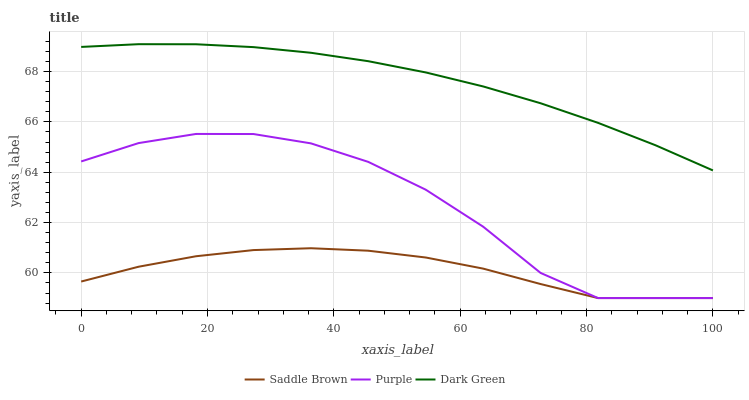Does Saddle Brown have the minimum area under the curve?
Answer yes or no. Yes. Does Dark Green have the maximum area under the curve?
Answer yes or no. Yes. Does Dark Green have the minimum area under the curve?
Answer yes or no. No. Does Saddle Brown have the maximum area under the curve?
Answer yes or no. No. Is Dark Green the smoothest?
Answer yes or no. Yes. Is Purple the roughest?
Answer yes or no. Yes. Is Saddle Brown the smoothest?
Answer yes or no. No. Is Saddle Brown the roughest?
Answer yes or no. No. Does Dark Green have the lowest value?
Answer yes or no. No. Does Dark Green have the highest value?
Answer yes or no. Yes. Does Saddle Brown have the highest value?
Answer yes or no. No. Is Saddle Brown less than Dark Green?
Answer yes or no. Yes. Is Dark Green greater than Purple?
Answer yes or no. Yes. Does Purple intersect Saddle Brown?
Answer yes or no. Yes. Is Purple less than Saddle Brown?
Answer yes or no. No. Is Purple greater than Saddle Brown?
Answer yes or no. No. Does Saddle Brown intersect Dark Green?
Answer yes or no. No. 